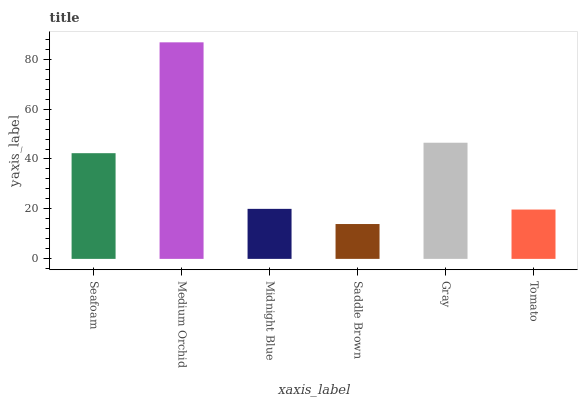Is Saddle Brown the minimum?
Answer yes or no. Yes. Is Medium Orchid the maximum?
Answer yes or no. Yes. Is Midnight Blue the minimum?
Answer yes or no. No. Is Midnight Blue the maximum?
Answer yes or no. No. Is Medium Orchid greater than Midnight Blue?
Answer yes or no. Yes. Is Midnight Blue less than Medium Orchid?
Answer yes or no. Yes. Is Midnight Blue greater than Medium Orchid?
Answer yes or no. No. Is Medium Orchid less than Midnight Blue?
Answer yes or no. No. Is Seafoam the high median?
Answer yes or no. Yes. Is Midnight Blue the low median?
Answer yes or no. Yes. Is Midnight Blue the high median?
Answer yes or no. No. Is Gray the low median?
Answer yes or no. No. 